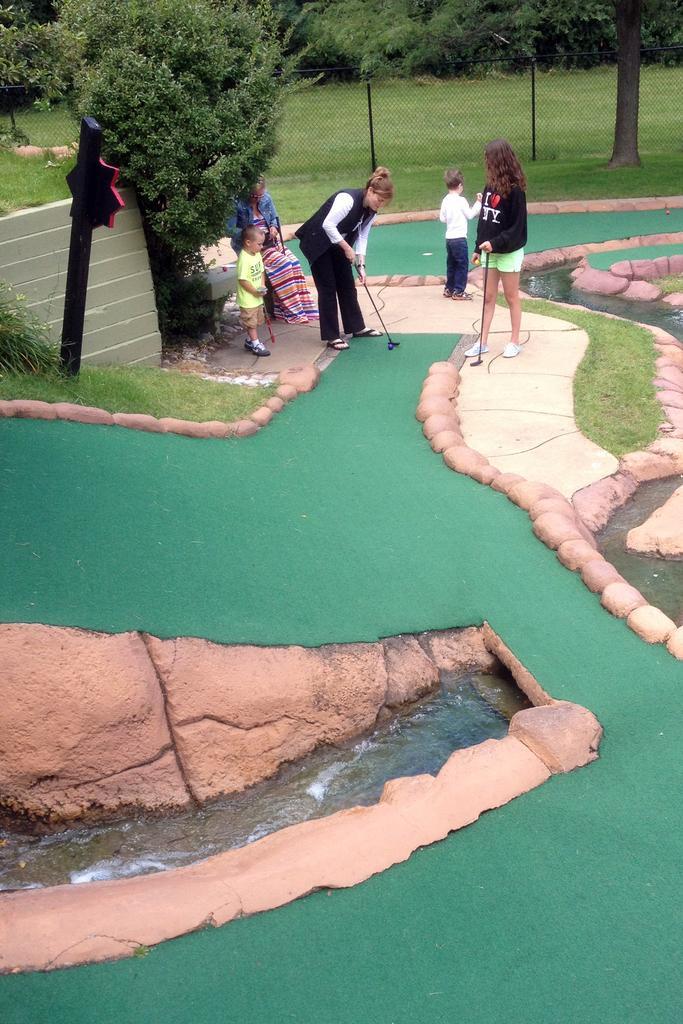Could you give a brief overview of what you see in this image? In this image, we can see people and some are holding sticks. In the background, there are trees and we can see a mesh, a board and at the bottom, there is water and ground. 